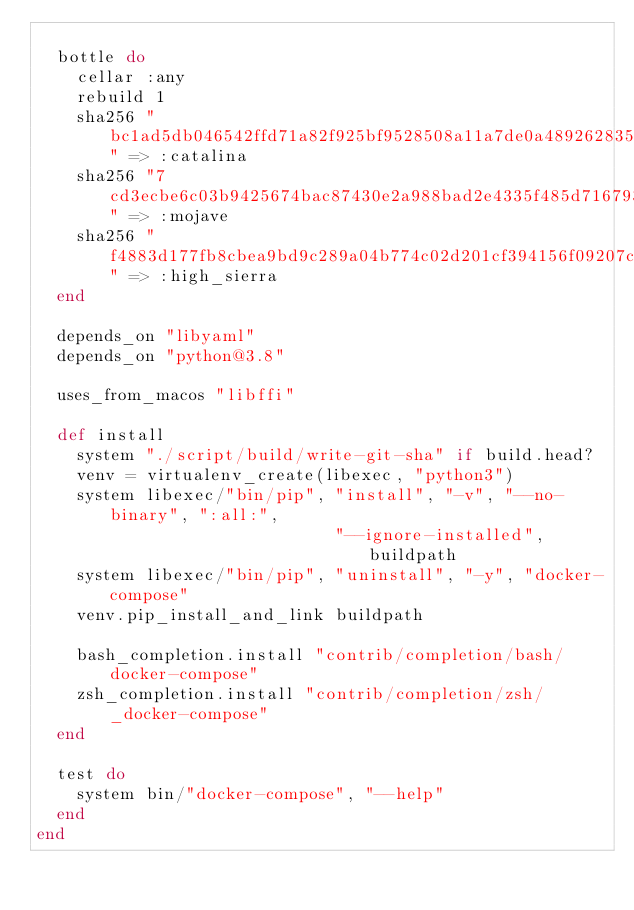<code> <loc_0><loc_0><loc_500><loc_500><_Ruby_>
  bottle do
    cellar :any
    rebuild 1
    sha256 "bc1ad5db046542ffd71a82f925bf9528508a11a7de0a48926283523513b218a5" => :catalina
    sha256 "7cd3ecbe6c03b9425674bac87430e2a988bad2e4335f485d71679348ff7226c5" => :mojave
    sha256 "f4883d177fb8cbea9bd9c289a04b774c02d201cf394156f09207cdcf3ad9d2da" => :high_sierra
  end

  depends_on "libyaml"
  depends_on "python@3.8"

  uses_from_macos "libffi"

  def install
    system "./script/build/write-git-sha" if build.head?
    venv = virtualenv_create(libexec, "python3")
    system libexec/"bin/pip", "install", "-v", "--no-binary", ":all:",
                              "--ignore-installed", buildpath
    system libexec/"bin/pip", "uninstall", "-y", "docker-compose"
    venv.pip_install_and_link buildpath

    bash_completion.install "contrib/completion/bash/docker-compose"
    zsh_completion.install "contrib/completion/zsh/_docker-compose"
  end

  test do
    system bin/"docker-compose", "--help"
  end
end
</code> 